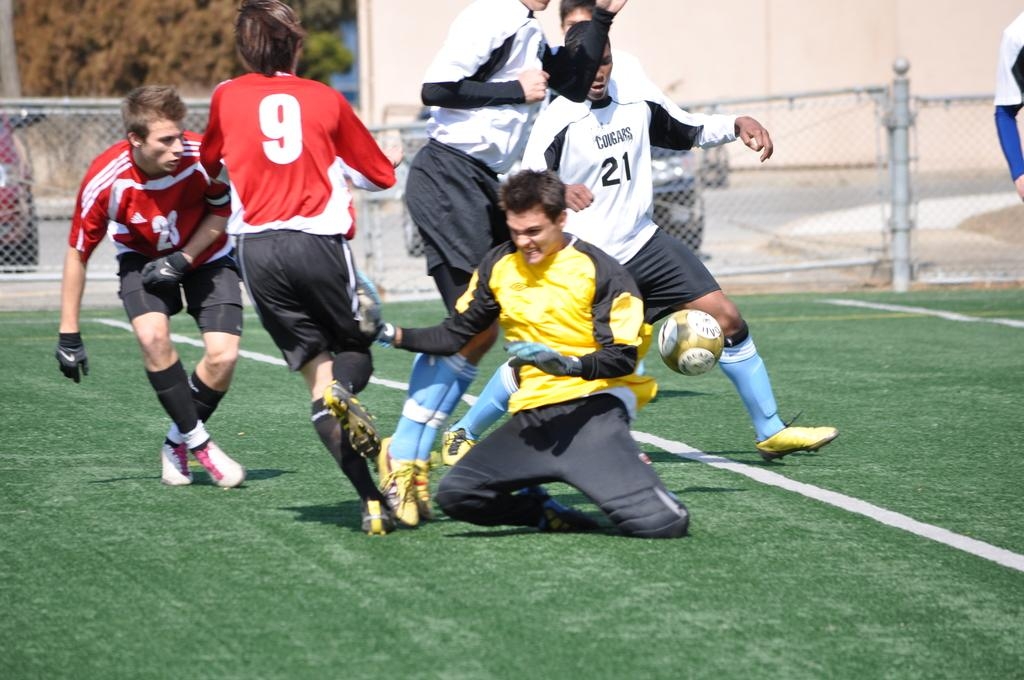<image>
Offer a succinct explanation of the picture presented. Player number 21 is trying to get control of the ball and score a goal. 